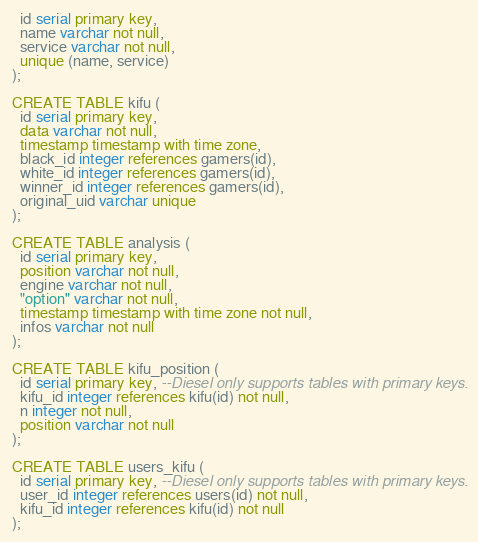<code> <loc_0><loc_0><loc_500><loc_500><_SQL_>  id serial primary key,
  name varchar not null,
  service varchar not null,
  unique (name, service)
);

CREATE TABLE kifu (
  id serial primary key,
  data varchar not null,
  timestamp timestamp with time zone,
  black_id integer references gamers(id),
  white_id integer references gamers(id),
  winner_id integer references gamers(id),
  original_uid varchar unique
);

CREATE TABLE analysis (
  id serial primary key,
  position varchar not null,
  engine varchar not null,
  "option" varchar not null,
  timestamp timestamp with time zone not null,
  infos varchar not null
);

CREATE TABLE kifu_position (
  id serial primary key, --Diesel only supports tables with primary keys.
  kifu_id integer references kifu(id) not null,
  n integer not null,
  position varchar not null
);

CREATE TABLE users_kifu (
  id serial primary key, --Diesel only supports tables with primary keys.
  user_id integer references users(id) not null,
  kifu_id integer references kifu(id) not null
);

</code> 